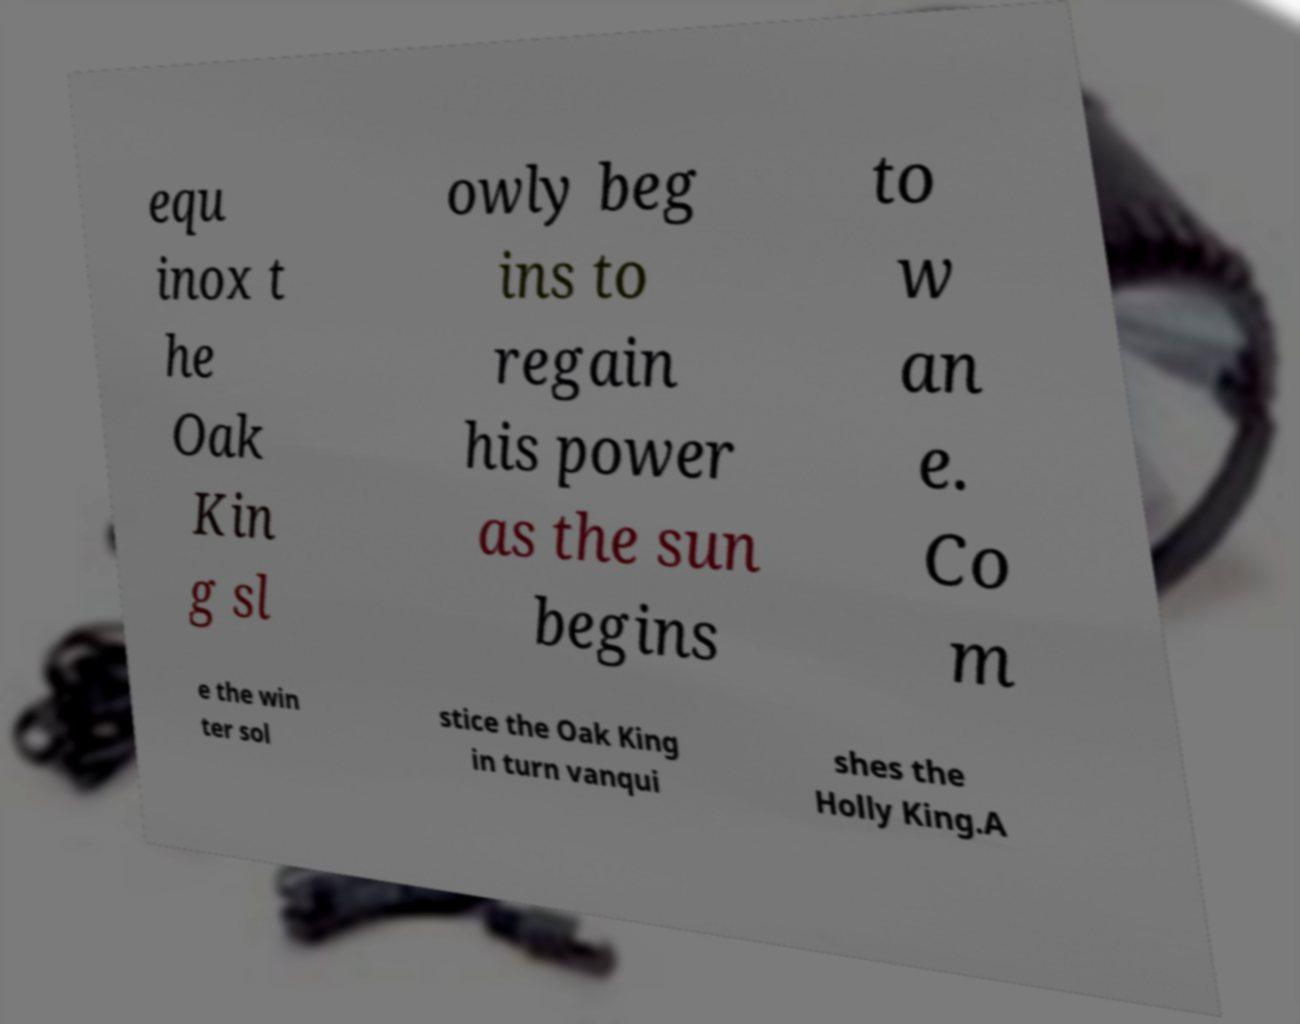There's text embedded in this image that I need extracted. Can you transcribe it verbatim? equ inox t he Oak Kin g sl owly beg ins to regain his power as the sun begins to w an e. Co m e the win ter sol stice the Oak King in turn vanqui shes the Holly King.A 